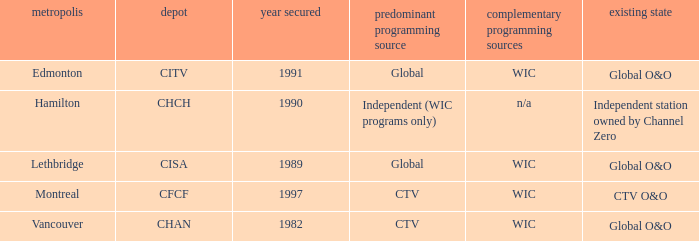Which station is located in edmonton CITV. 